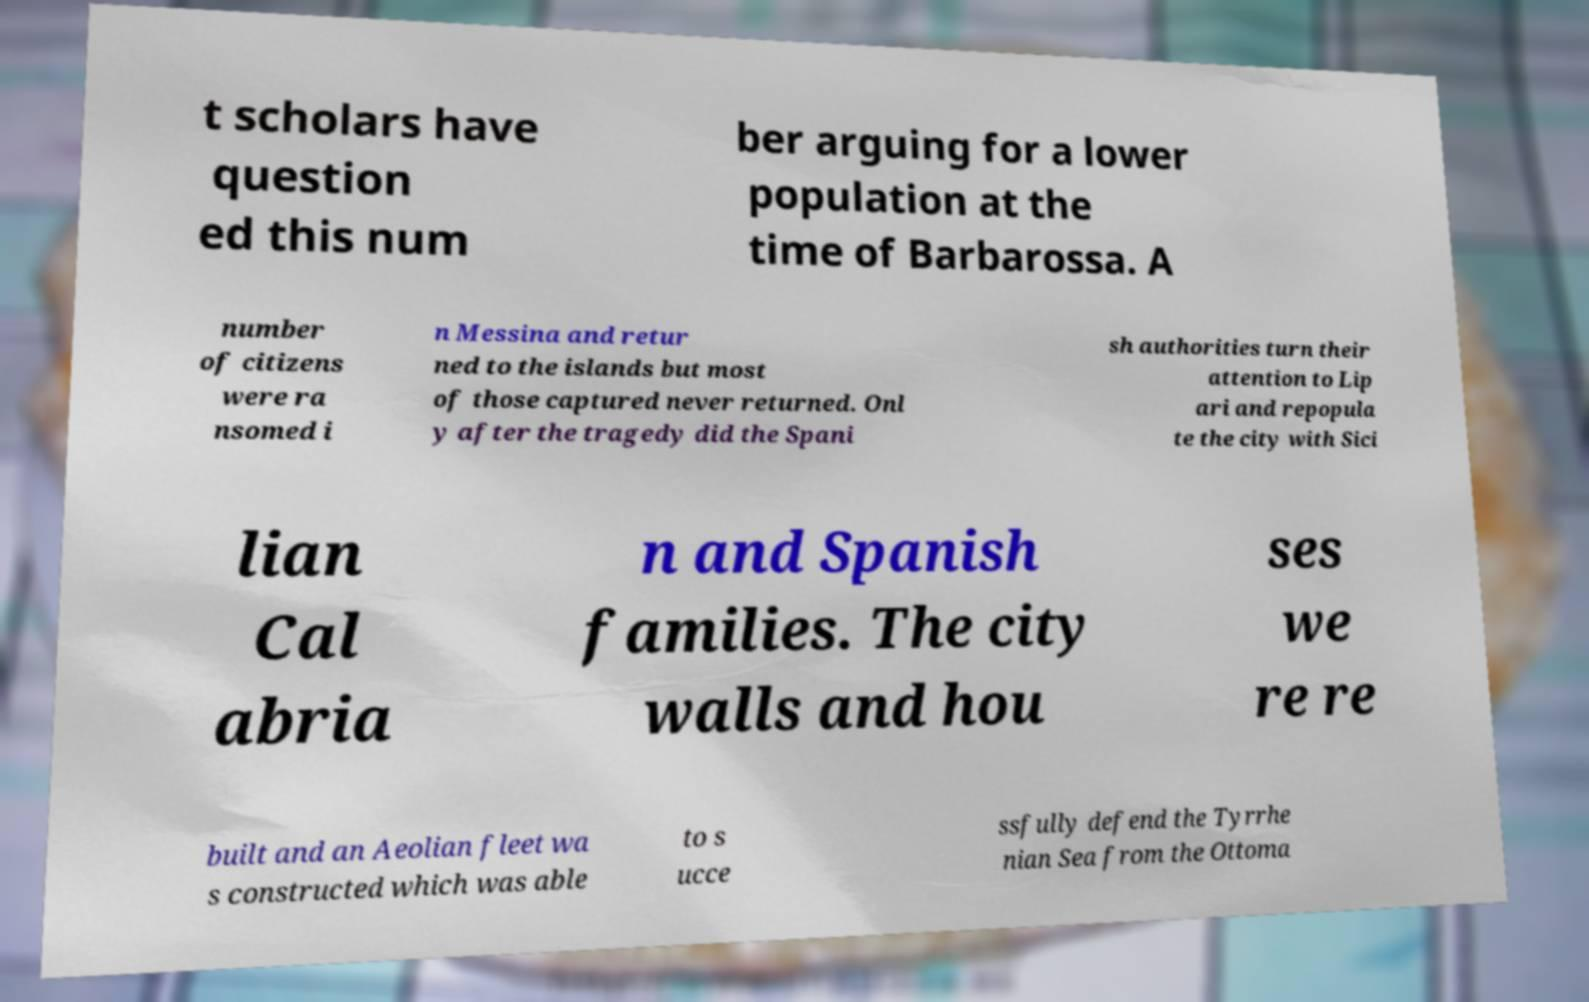Can you accurately transcribe the text from the provided image for me? t scholars have question ed this num ber arguing for a lower population at the time of Barbarossa. A number of citizens were ra nsomed i n Messina and retur ned to the islands but most of those captured never returned. Onl y after the tragedy did the Spani sh authorities turn their attention to Lip ari and repopula te the city with Sici lian Cal abria n and Spanish families. The city walls and hou ses we re re built and an Aeolian fleet wa s constructed which was able to s ucce ssfully defend the Tyrrhe nian Sea from the Ottoma 